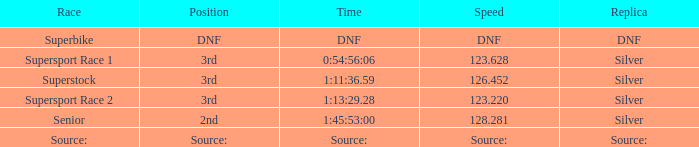Which race has a replica of DNF? Superbike. 